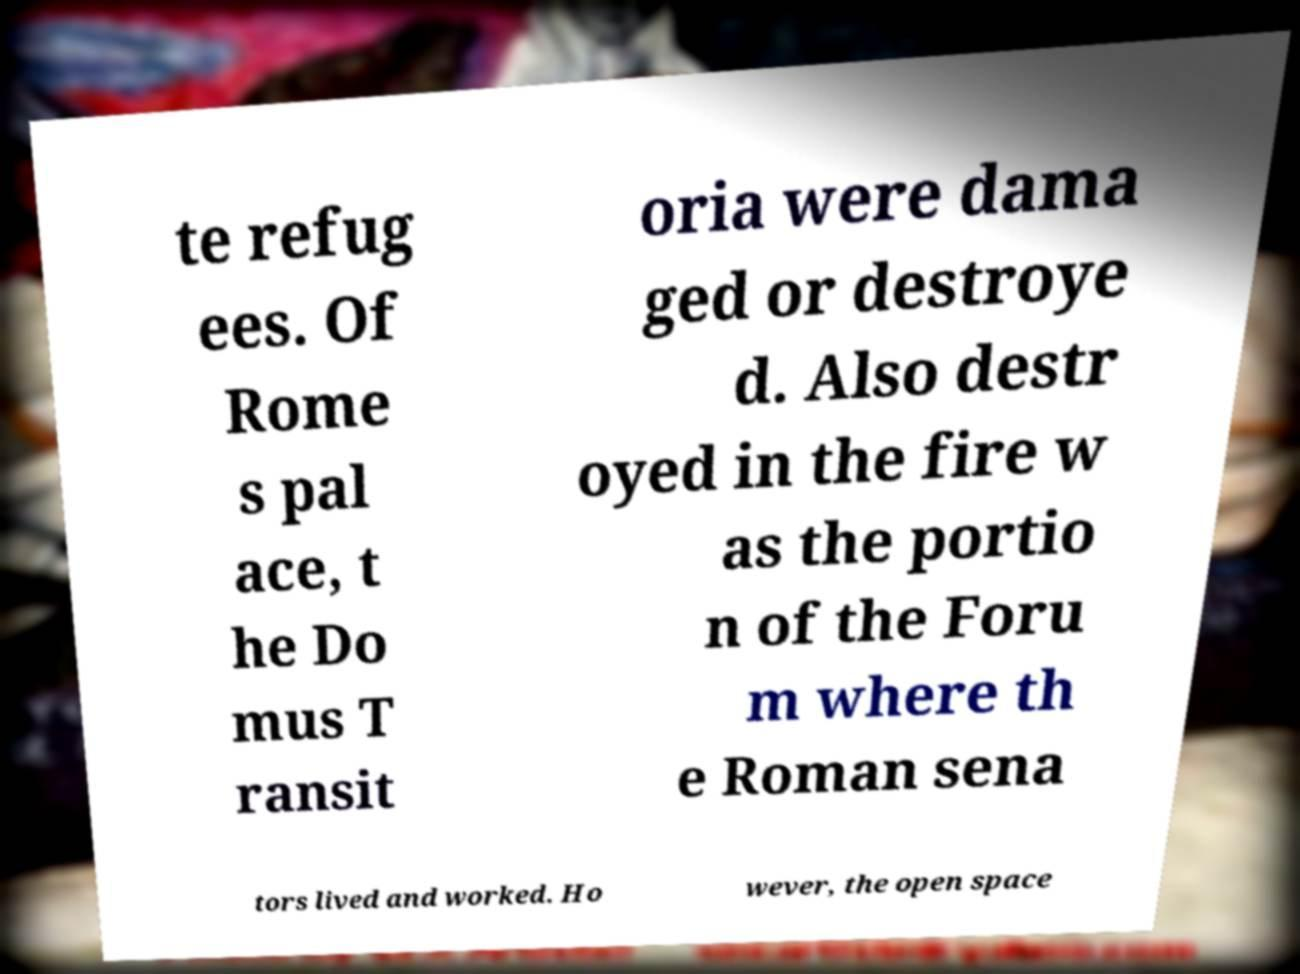Could you extract and type out the text from this image? te refug ees. Of Rome s pal ace, t he Do mus T ransit oria were dama ged or destroye d. Also destr oyed in the fire w as the portio n of the Foru m where th e Roman sena tors lived and worked. Ho wever, the open space 